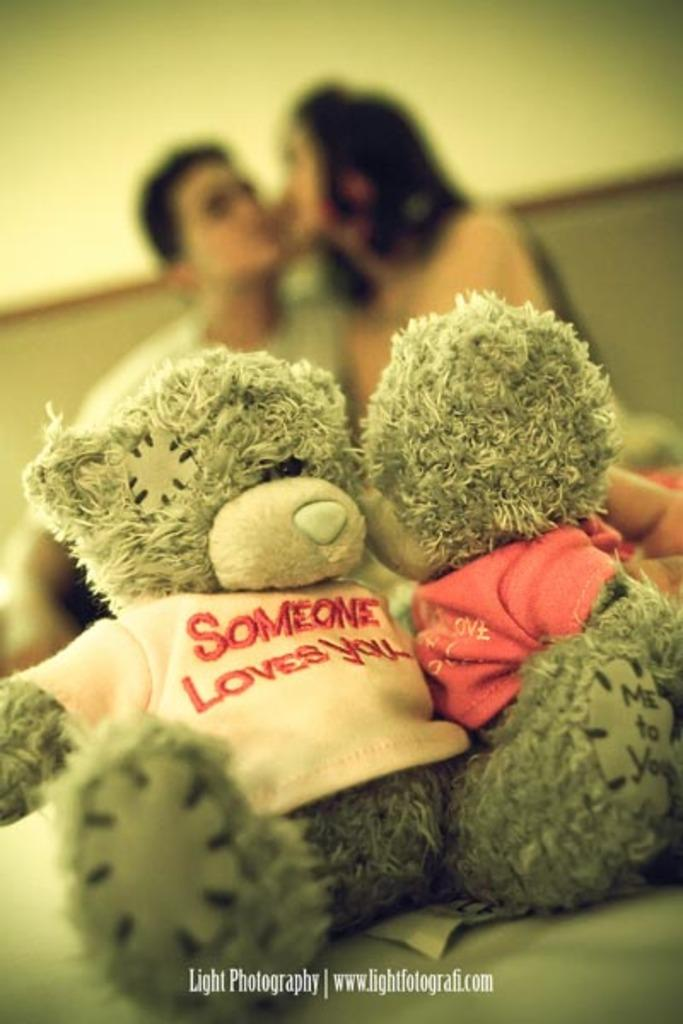What objects can be seen in the image? There are toys in the image. Can you describe the scene in the background of the image? There are two people and a wall in the background of the image. How would you describe the appearance of the background? The background of the image appears blurred. What type of letter is being written by the lake in the image? There is no lake or letter present in the image. Can you describe the hammer that is being used by the person in the image? There is no hammer or person present in the image. 